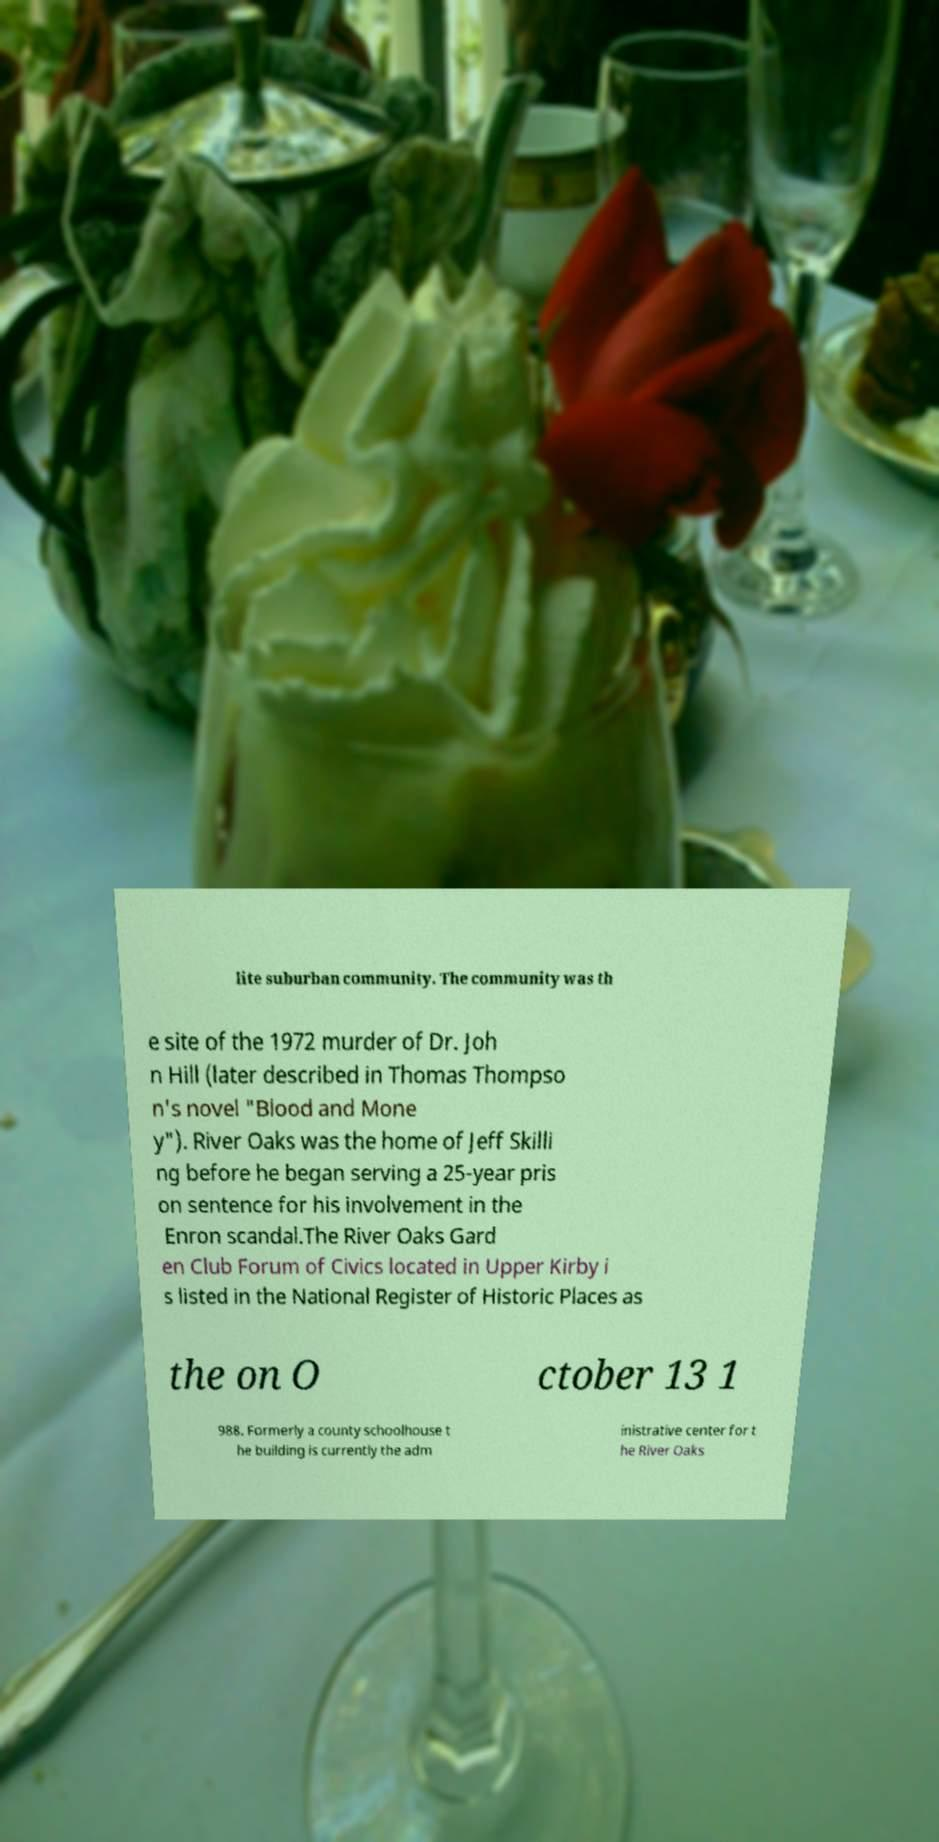There's text embedded in this image that I need extracted. Can you transcribe it verbatim? lite suburban community. The community was th e site of the 1972 murder of Dr. Joh n Hill (later described in Thomas Thompso n's novel "Blood and Mone y"). River Oaks was the home of Jeff Skilli ng before he began serving a 25-year pris on sentence for his involvement in the Enron scandal.The River Oaks Gard en Club Forum of Civics located in Upper Kirby i s listed in the National Register of Historic Places as the on O ctober 13 1 988. Formerly a county schoolhouse t he building is currently the adm inistrative center for t he River Oaks 